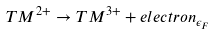<formula> <loc_0><loc_0><loc_500><loc_500>T M ^ { 2 + } \rightarrow T M ^ { 3 + } + e l e c t r o n _ { \epsilon _ { F } }</formula> 